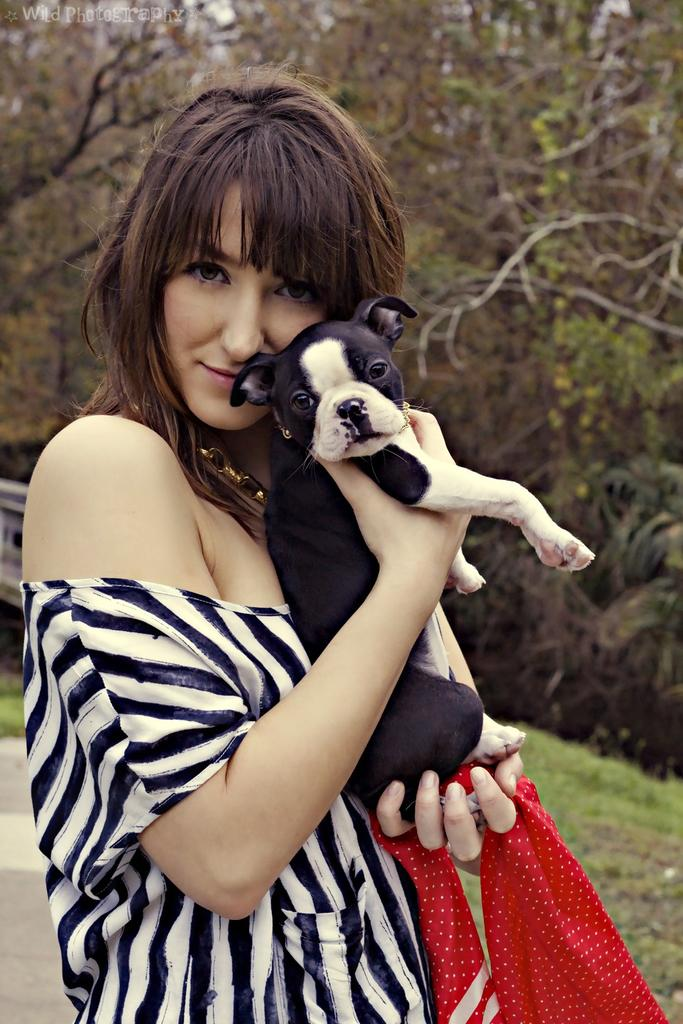Who is present in the image? There is a woman in the image. What is the woman holding in the image? The woman is holding a dog with her hands. What type of surface is visible in the image? There is grass visible in the image. What other natural elements can be seen in the image? There are trees in the image. What type of bells can be heard ringing in the image? There are no bells present in the image, and therefore no sounds can be heard. 